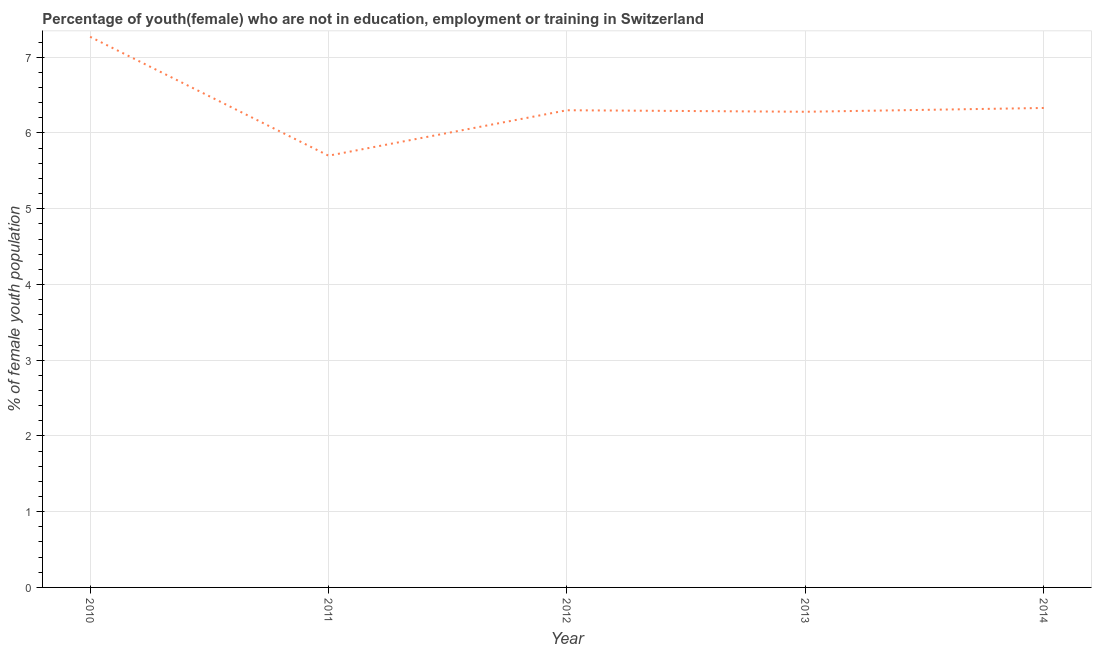What is the unemployed female youth population in 2010?
Provide a succinct answer. 7.27. Across all years, what is the maximum unemployed female youth population?
Make the answer very short. 7.27. Across all years, what is the minimum unemployed female youth population?
Ensure brevity in your answer.  5.7. In which year was the unemployed female youth population maximum?
Offer a terse response. 2010. In which year was the unemployed female youth population minimum?
Offer a very short reply. 2011. What is the sum of the unemployed female youth population?
Offer a terse response. 31.88. What is the difference between the unemployed female youth population in 2011 and 2014?
Make the answer very short. -0.63. What is the average unemployed female youth population per year?
Offer a terse response. 6.38. What is the median unemployed female youth population?
Keep it short and to the point. 6.3. What is the ratio of the unemployed female youth population in 2012 to that in 2014?
Give a very brief answer. 1. Is the unemployed female youth population in 2010 less than that in 2011?
Ensure brevity in your answer.  No. Is the difference between the unemployed female youth population in 2011 and 2013 greater than the difference between any two years?
Keep it short and to the point. No. What is the difference between the highest and the second highest unemployed female youth population?
Your answer should be very brief. 0.94. What is the difference between the highest and the lowest unemployed female youth population?
Offer a terse response. 1.57. In how many years, is the unemployed female youth population greater than the average unemployed female youth population taken over all years?
Offer a very short reply. 1. How many years are there in the graph?
Ensure brevity in your answer.  5. What is the difference between two consecutive major ticks on the Y-axis?
Make the answer very short. 1. Are the values on the major ticks of Y-axis written in scientific E-notation?
Your answer should be very brief. No. What is the title of the graph?
Provide a short and direct response. Percentage of youth(female) who are not in education, employment or training in Switzerland. What is the label or title of the Y-axis?
Provide a succinct answer. % of female youth population. What is the % of female youth population of 2010?
Provide a short and direct response. 7.27. What is the % of female youth population in 2011?
Make the answer very short. 5.7. What is the % of female youth population of 2012?
Keep it short and to the point. 6.3. What is the % of female youth population in 2013?
Keep it short and to the point. 6.28. What is the % of female youth population in 2014?
Offer a very short reply. 6.33. What is the difference between the % of female youth population in 2010 and 2011?
Your response must be concise. 1.57. What is the difference between the % of female youth population in 2010 and 2014?
Provide a short and direct response. 0.94. What is the difference between the % of female youth population in 2011 and 2012?
Your answer should be compact. -0.6. What is the difference between the % of female youth population in 2011 and 2013?
Keep it short and to the point. -0.58. What is the difference between the % of female youth population in 2011 and 2014?
Offer a terse response. -0.63. What is the difference between the % of female youth population in 2012 and 2013?
Give a very brief answer. 0.02. What is the difference between the % of female youth population in 2012 and 2014?
Give a very brief answer. -0.03. What is the ratio of the % of female youth population in 2010 to that in 2011?
Your response must be concise. 1.27. What is the ratio of the % of female youth population in 2010 to that in 2012?
Offer a terse response. 1.15. What is the ratio of the % of female youth population in 2010 to that in 2013?
Give a very brief answer. 1.16. What is the ratio of the % of female youth population in 2010 to that in 2014?
Give a very brief answer. 1.15. What is the ratio of the % of female youth population in 2011 to that in 2012?
Your answer should be compact. 0.91. What is the ratio of the % of female youth population in 2011 to that in 2013?
Provide a short and direct response. 0.91. What is the ratio of the % of female youth population in 2011 to that in 2014?
Give a very brief answer. 0.9. What is the ratio of the % of female youth population in 2012 to that in 2013?
Make the answer very short. 1. What is the ratio of the % of female youth population in 2013 to that in 2014?
Your response must be concise. 0.99. 